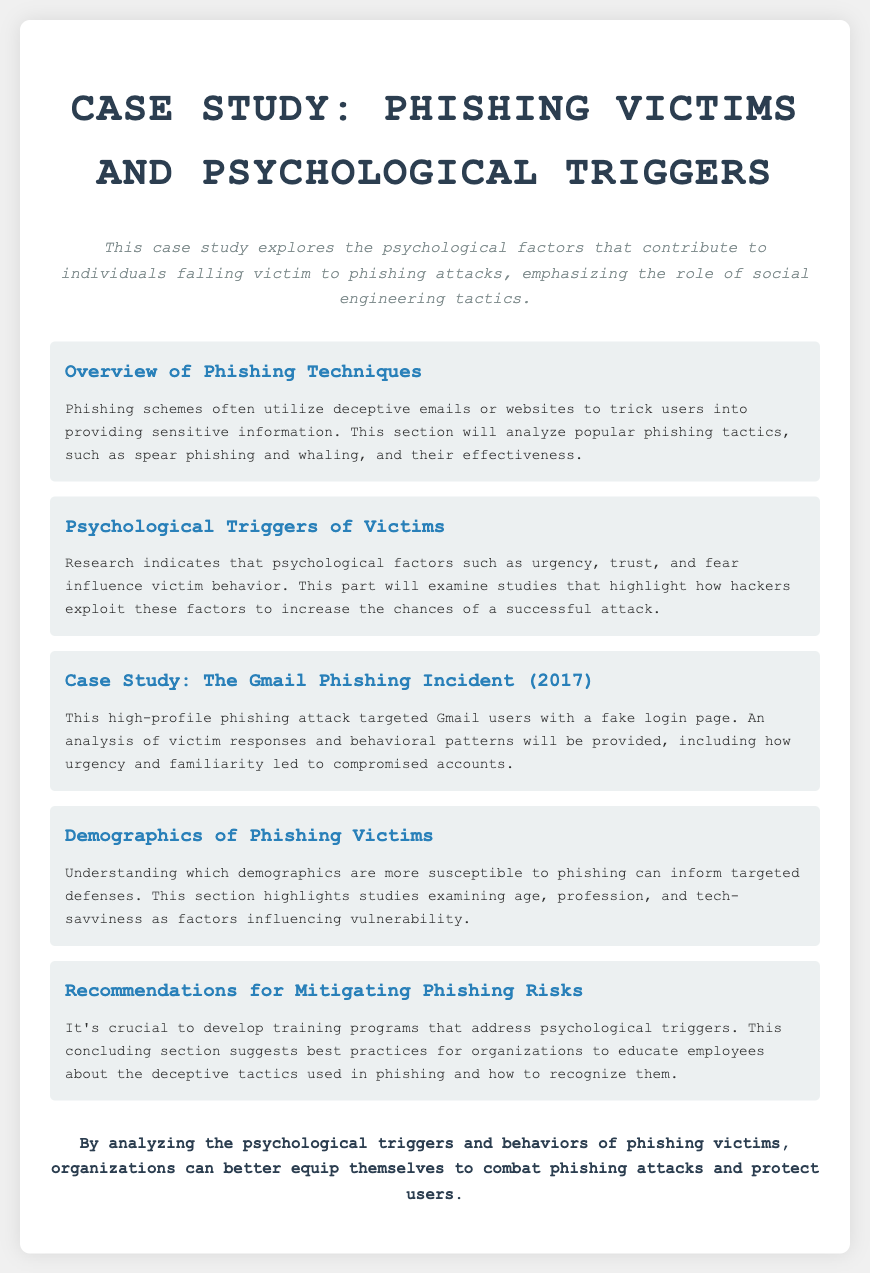What is the primary focus of the case study? The primary focus of the case study is to explore psychological factors contributing to phishing victimization, especially social engineering tactics.
Answer: Psychological factors and social engineering tactics What phishing technique is analyzed in the overview section? The overview section discusses various phishing tactics, including spear phishing and whaling, as popular phishing schemes.
Answer: Spear phishing and whaling Which psychological factor is mentioned as influencing victim behavior? The document states urgency, trust, and fear as psychological factors that influence phishing victims' behavior.
Answer: Urgency, trust, and fear What year did the Gmail phishing incident occur? The Gmail phishing incident is specifically mentioned to have occurred in 2017.
Answer: 2017 What demographic factors are highlighted in the demographics section? The demographics section emphasizes age, profession, and tech-savviness as factors influencing phishing vulnerability.
Answer: Age, profession, and tech-savviness What type of training programs are recommended for organizations? The document suggests developing training programs that specifically address psychological triggers used in phishing.
Answer: Training programs addressing psychological triggers How does the case study suggest users can be better equipped against phishing? The conclusion discusses analyzing psychological triggers and victim behaviors as a method for organizations to enhance their phishing defense.
Answer: Analyzing psychological triggers and victim behaviors 